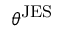<formula> <loc_0><loc_0><loc_500><loc_500>\theta ^ { J E S }</formula> 